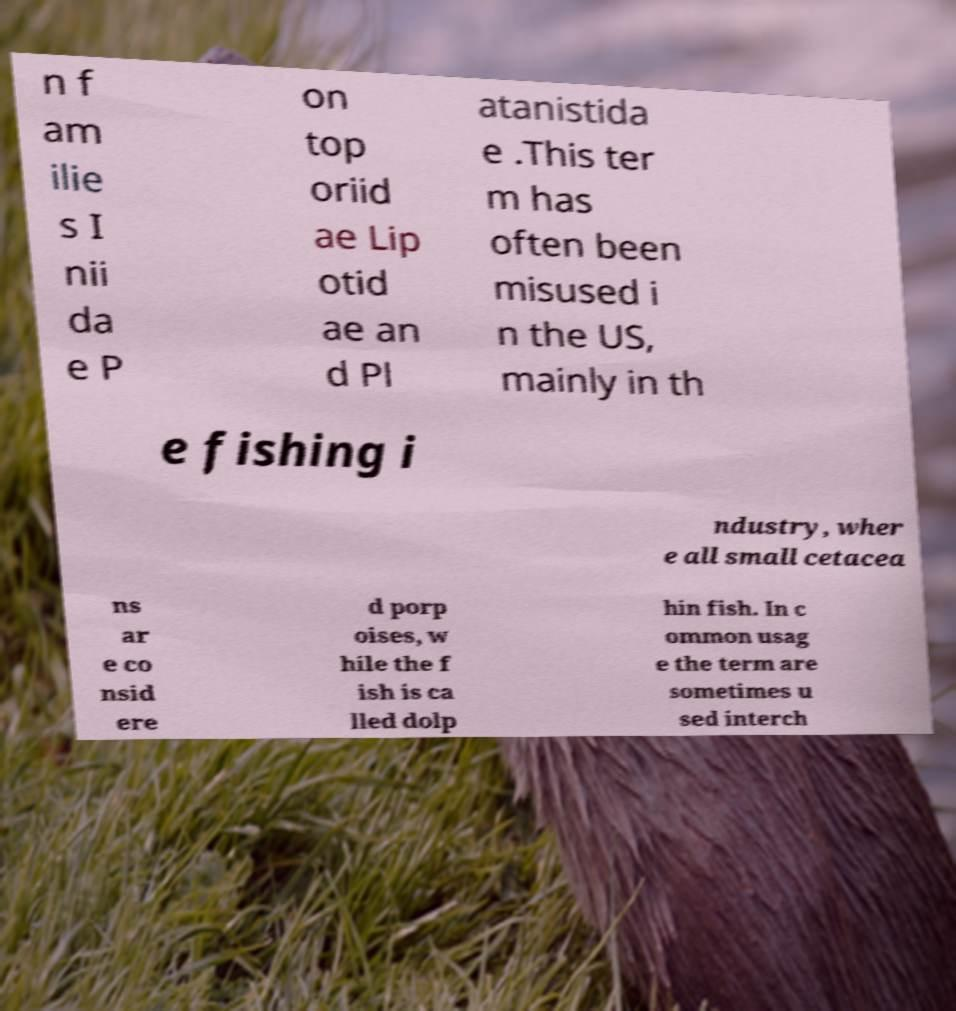For documentation purposes, I need the text within this image transcribed. Could you provide that? n f am ilie s I nii da e P on top oriid ae Lip otid ae an d Pl atanistida e .This ter m has often been misused i n the US, mainly in th e fishing i ndustry, wher e all small cetacea ns ar e co nsid ere d porp oises, w hile the f ish is ca lled dolp hin fish. In c ommon usag e the term are sometimes u sed interch 